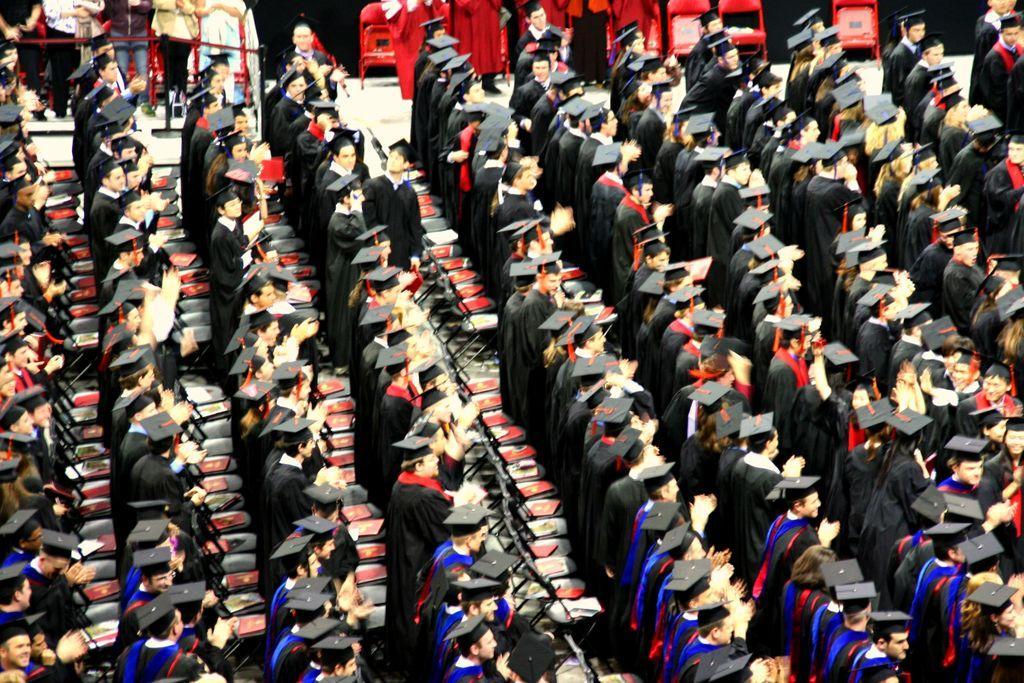Please provide a concise description of this image. In this image I can see so many people wearing black coats and hats. It looks like a convocation hall.  